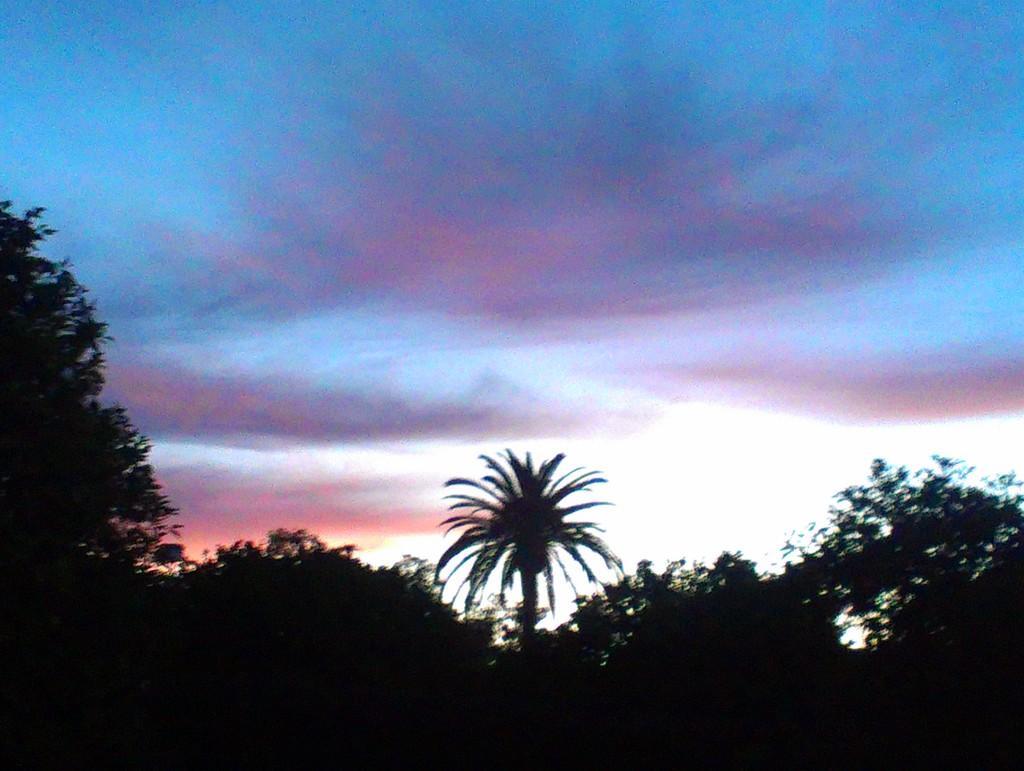Please provide a concise description of this image. In this image we can see many trees. We can see the clouds in the sky. 